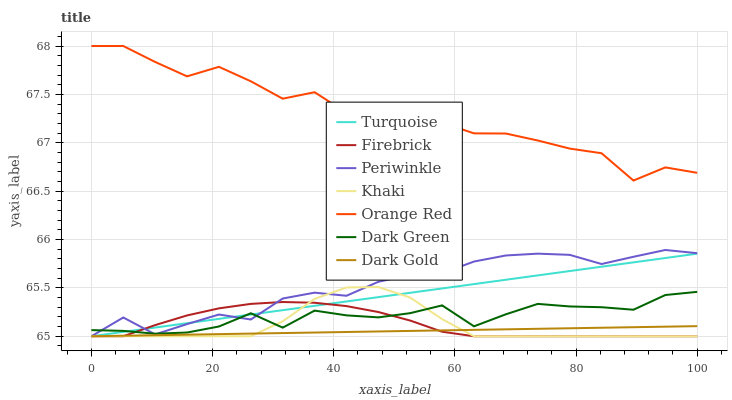Does Dark Gold have the minimum area under the curve?
Answer yes or no. Yes. Does Orange Red have the maximum area under the curve?
Answer yes or no. Yes. Does Khaki have the minimum area under the curve?
Answer yes or no. No. Does Khaki have the maximum area under the curve?
Answer yes or no. No. Is Turquoise the smoothest?
Answer yes or no. Yes. Is Orange Red the roughest?
Answer yes or no. Yes. Is Khaki the smoothest?
Answer yes or no. No. Is Khaki the roughest?
Answer yes or no. No. Does Turquoise have the lowest value?
Answer yes or no. Yes. Does Orange Red have the lowest value?
Answer yes or no. No. Does Orange Red have the highest value?
Answer yes or no. Yes. Does Khaki have the highest value?
Answer yes or no. No. Is Khaki less than Orange Red?
Answer yes or no. Yes. Is Orange Red greater than Firebrick?
Answer yes or no. Yes. Does Dark Green intersect Khaki?
Answer yes or no. Yes. Is Dark Green less than Khaki?
Answer yes or no. No. Is Dark Green greater than Khaki?
Answer yes or no. No. Does Khaki intersect Orange Red?
Answer yes or no. No. 